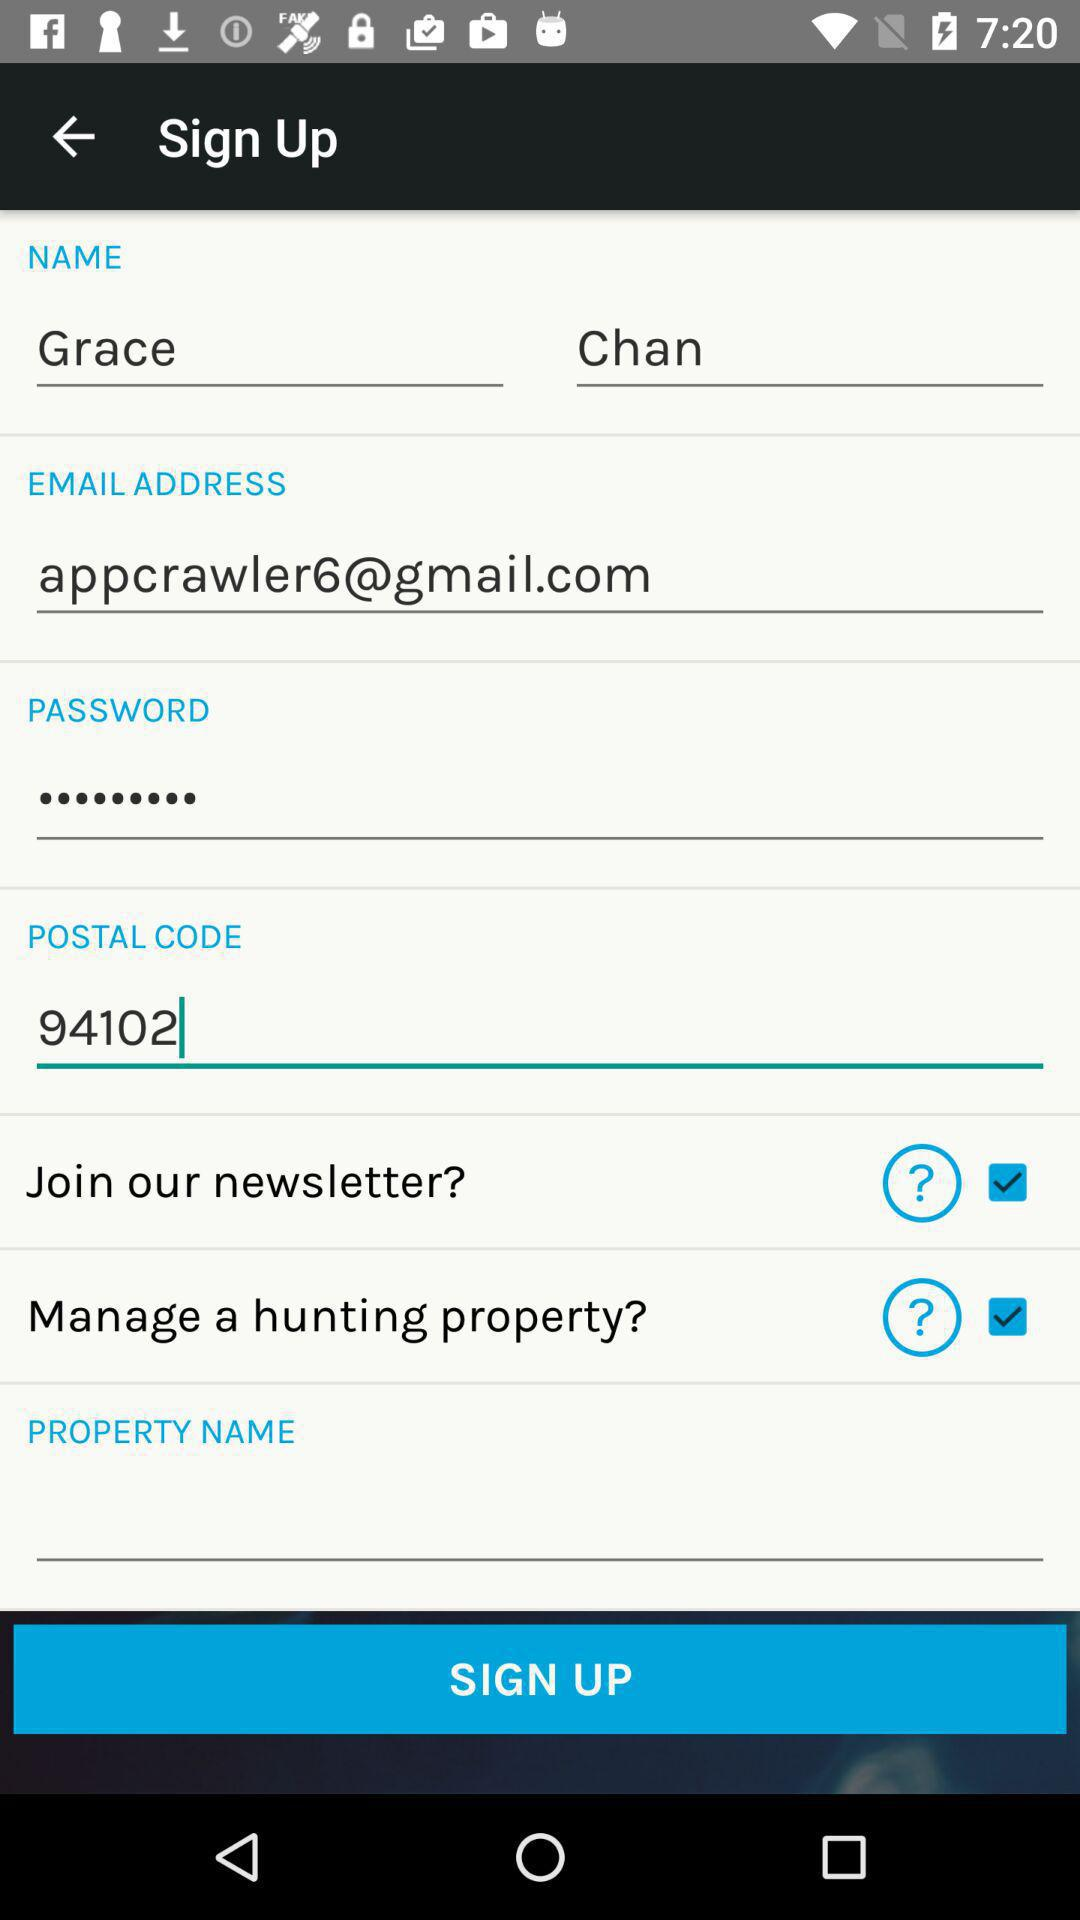What is the name of the user? The name of the user is Grace Chan. 